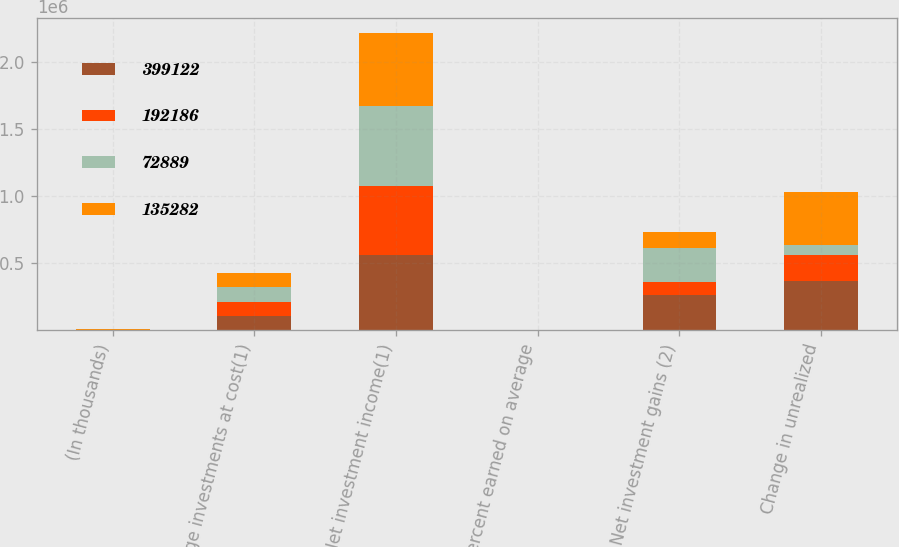Convert chart. <chart><loc_0><loc_0><loc_500><loc_500><stacked_bar_chart><ecel><fcel>(In thousands)<fcel>Average investments at cost(1)<fcel>Net investment income(1)<fcel>Percent earned on average<fcel>Net investment gains (2)<fcel>Change in unrealized<nl><fcel>399122<fcel>2016<fcel>106934<fcel>564163<fcel>3.4<fcel>267005<fcel>371716<nl><fcel>192186<fcel>2015<fcel>106934<fcel>512645<fcel>3.2<fcel>92324<fcel>192186<nl><fcel>72889<fcel>2014<fcel>106934<fcel>600885<fcel>3.9<fcel>254852<fcel>72889<nl><fcel>135282<fcel>2013<fcel>106934<fcel>544291<fcel>3.7<fcel>121544<fcel>399122<nl></chart> 